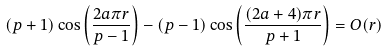<formula> <loc_0><loc_0><loc_500><loc_500>( p + 1 ) \cos \left ( \frac { 2 a \pi r } { p - 1 } \right ) - ( p - 1 ) \cos \left ( \frac { ( 2 a + 4 ) \pi r } { p + 1 } \right ) = O ( r )</formula> 